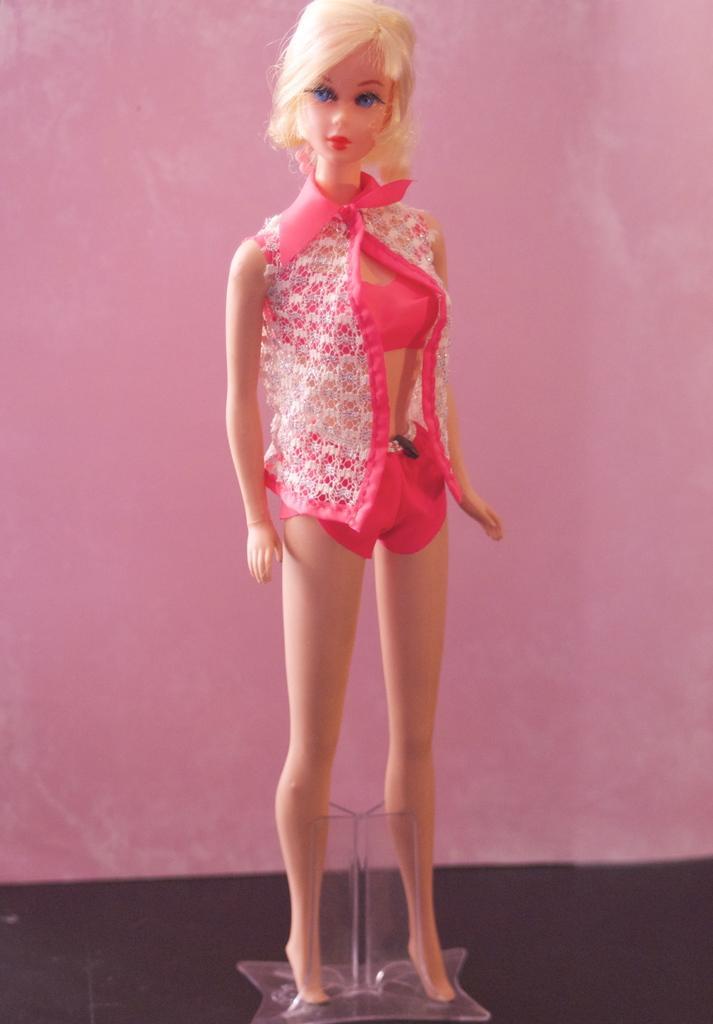In one or two sentences, can you explain what this image depicts? In this image in the center there is one toy and in the background there is a wall, at the bottom there is glass box. 